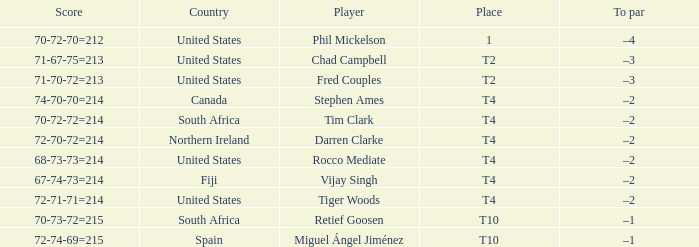What is Rocco Mediate's par? –2. 